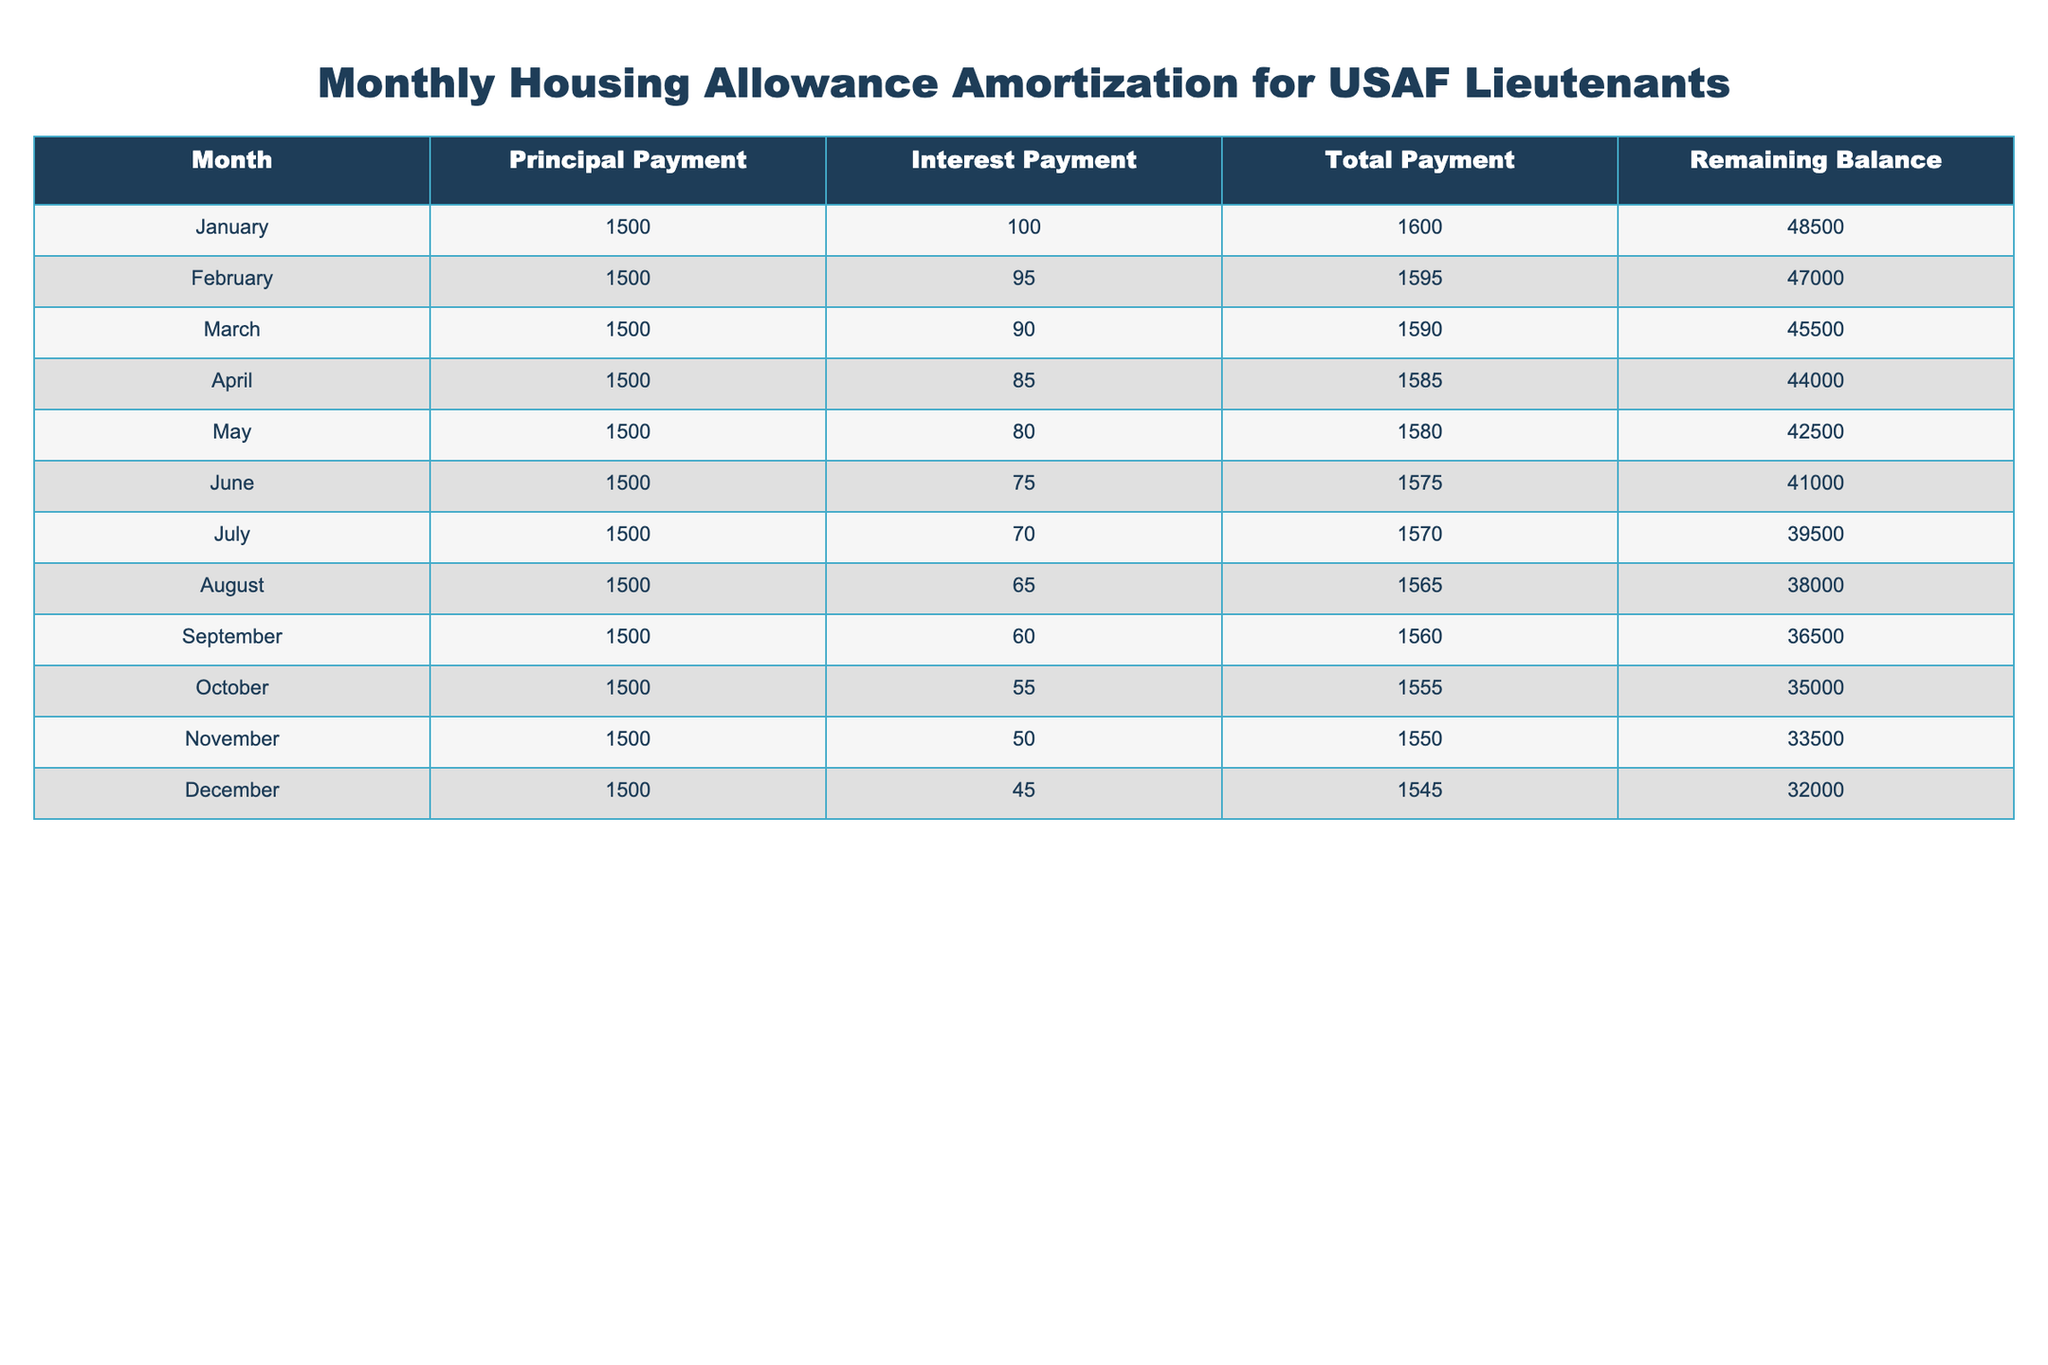What's the total payment made in March? In March, the table shows a total payment of 1590.
Answer: 1590 What is the remaining balance after the October payment? After the payment in October, the remaining balance is 35000.
Answer: 35000 What is the average principal payment made over the year? There are 12 months and the principal payment is 1500 each month, so the total for the year is 1500 * 12 = 18000. The average is 18000 / 12 = 1500.
Answer: 1500 Did the interest payment decrease every month? By looking at the interest payments listed from January to December, they decrease from 100 to 45, confirming that the interest payment did decrease every month.
Answer: Yes What is the difference between the total payments in January and December? The total payment in January is 1600 and in December is 1545. The difference is 1600 - 1545 = 55.
Answer: 55 How much was the total interest paid by the end of the year? To find the total interest paid for the year, we sum the interest payments for each month: 100 + 95 + 90 + 85 + 80 + 75 + 70 + 65 + 60 + 55 + 50 + 45 = 1000.
Answer: 1000 If I continue this payment schedule, what will the remaining balance be after 6 months? After 6 months, the total principal paid is 1500 * 6 = 9000. Starting with 50000 and deducting 9000 gives a remaining balance of 41000 after 6 months.
Answer: 41000 What were the total payments made in the first half of the year (January to June)? Sum of total payments from January to June: 1600 + 1595 + 1590 + 1585 + 1580 + 1575 = 9525.
Answer: 9525 Is the total payment in May higher than that in November? The total payment in May is 1580, and for November, it is 1550. Since 1580 > 1550, the statement is true.
Answer: Yes 